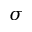<formula> <loc_0><loc_0><loc_500><loc_500>\sigma</formula> 